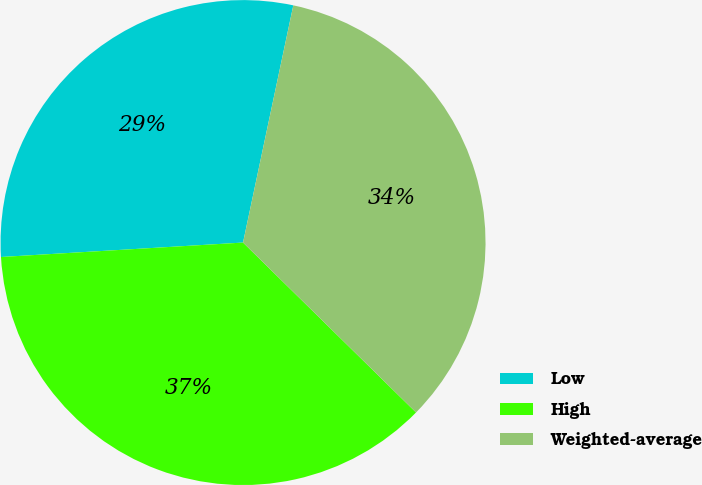<chart> <loc_0><loc_0><loc_500><loc_500><pie_chart><fcel>Low<fcel>High<fcel>Weighted-average<nl><fcel>29.27%<fcel>36.69%<fcel>34.03%<nl></chart> 